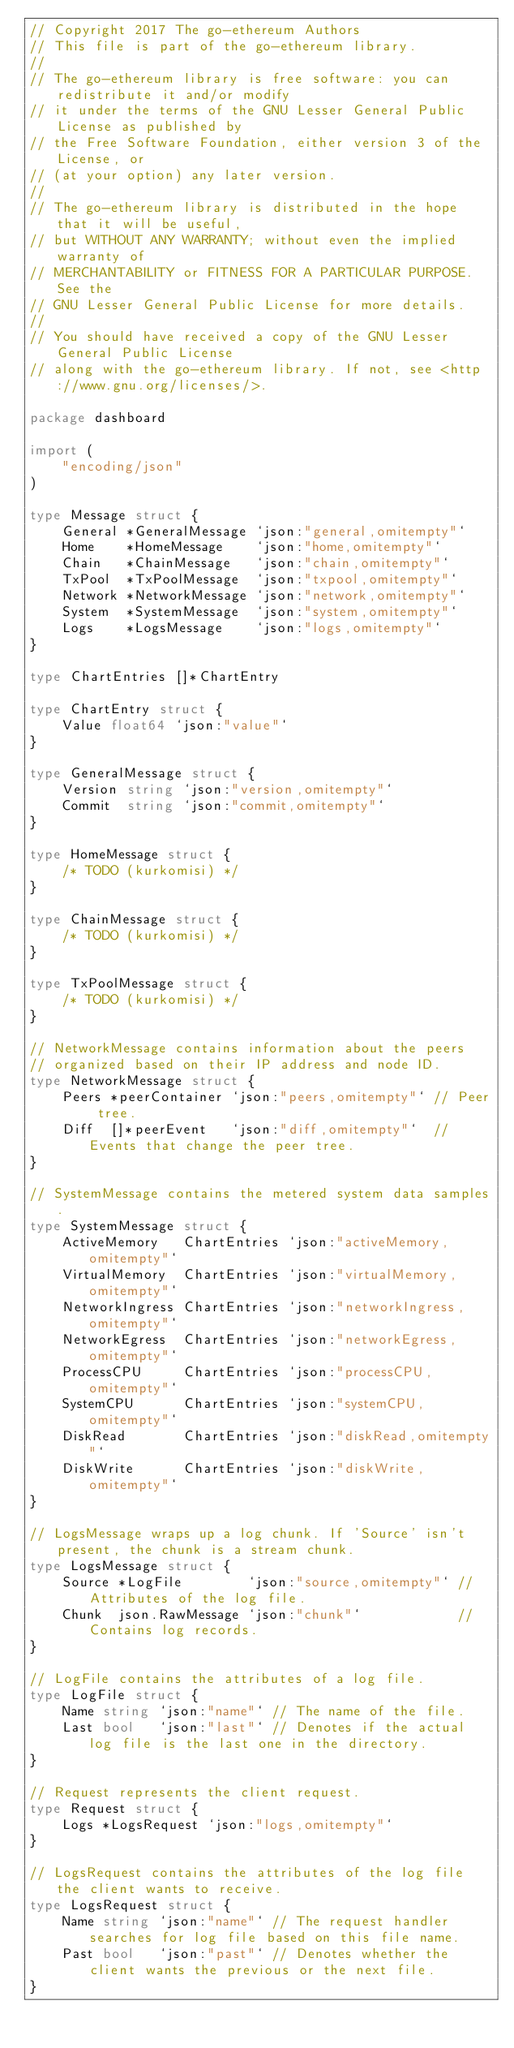<code> <loc_0><loc_0><loc_500><loc_500><_Go_>// Copyright 2017 The go-ethereum Authors
// This file is part of the go-ethereum library.
//
// The go-ethereum library is free software: you can redistribute it and/or modify
// it under the terms of the GNU Lesser General Public License as published by
// the Free Software Foundation, either version 3 of the License, or
// (at your option) any later version.
//
// The go-ethereum library is distributed in the hope that it will be useful,
// but WITHOUT ANY WARRANTY; without even the implied warranty of
// MERCHANTABILITY or FITNESS FOR A PARTICULAR PURPOSE. See the
// GNU Lesser General Public License for more details.
//
// You should have received a copy of the GNU Lesser General Public License
// along with the go-ethereum library. If not, see <http://www.gnu.org/licenses/>.

package dashboard

import (
	"encoding/json"
)

type Message struct {
	General *GeneralMessage `json:"general,omitempty"`
	Home    *HomeMessage    `json:"home,omitempty"`
	Chain   *ChainMessage   `json:"chain,omitempty"`
	TxPool  *TxPoolMessage  `json:"txpool,omitempty"`
	Network *NetworkMessage `json:"network,omitempty"`
	System  *SystemMessage  `json:"system,omitempty"`
	Logs    *LogsMessage    `json:"logs,omitempty"`
}

type ChartEntries []*ChartEntry

type ChartEntry struct {
	Value float64 `json:"value"`
}

type GeneralMessage struct {
	Version string `json:"version,omitempty"`
	Commit  string `json:"commit,omitempty"`
}

type HomeMessage struct {
	/* TODO (kurkomisi) */
}

type ChainMessage struct {
	/* TODO (kurkomisi) */
}

type TxPoolMessage struct {
	/* TODO (kurkomisi) */
}

// NetworkMessage contains information about the peers
// organized based on their IP address and node ID.
type NetworkMessage struct {
	Peers *peerContainer `json:"peers,omitempty"` // Peer tree.
	Diff  []*peerEvent   `json:"diff,omitempty"`  // Events that change the peer tree.
}

// SystemMessage contains the metered system data samples.
type SystemMessage struct {
	ActiveMemory   ChartEntries `json:"activeMemory,omitempty"`
	VirtualMemory  ChartEntries `json:"virtualMemory,omitempty"`
	NetworkIngress ChartEntries `json:"networkIngress,omitempty"`
	NetworkEgress  ChartEntries `json:"networkEgress,omitempty"`
	ProcessCPU     ChartEntries `json:"processCPU,omitempty"`
	SystemCPU      ChartEntries `json:"systemCPU,omitempty"`
	DiskRead       ChartEntries `json:"diskRead,omitempty"`
	DiskWrite      ChartEntries `json:"diskWrite,omitempty"`
}

// LogsMessage wraps up a log chunk. If 'Source' isn't present, the chunk is a stream chunk.
type LogsMessage struct {
	Source *LogFile        `json:"source,omitempty"` // Attributes of the log file.
	Chunk  json.RawMessage `json:"chunk"`            // Contains log records.
}

// LogFile contains the attributes of a log file.
type LogFile struct {
	Name string `json:"name"` // The name of the file.
	Last bool   `json:"last"` // Denotes if the actual log file is the last one in the directory.
}

// Request represents the client request.
type Request struct {
	Logs *LogsRequest `json:"logs,omitempty"`
}

// LogsRequest contains the attributes of the log file the client wants to receive.
type LogsRequest struct {
	Name string `json:"name"` // The request handler searches for log file based on this file name.
	Past bool   `json:"past"` // Denotes whether the client wants the previous or the next file.
}
</code> 